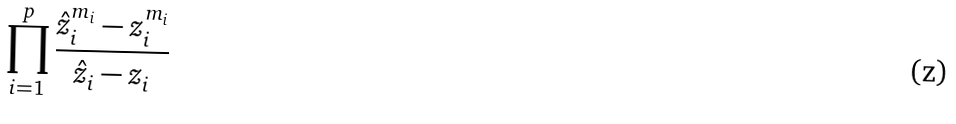Convert formula to latex. <formula><loc_0><loc_0><loc_500><loc_500>\prod _ { i = 1 } ^ { p } \frac { \hat { z } _ { i } ^ { m _ { i } } - z _ { i } ^ { m _ { i } } } { \hat { z } _ { i } - z _ { i } }</formula> 